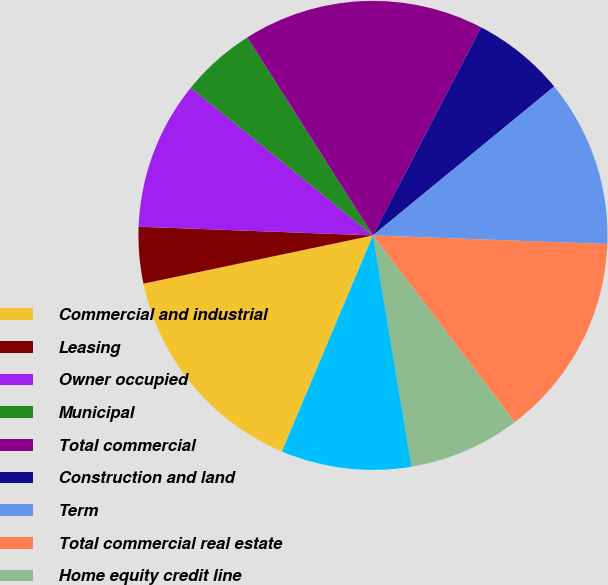Convert chart to OTSL. <chart><loc_0><loc_0><loc_500><loc_500><pie_chart><fcel>Commercial and industrial<fcel>Leasing<fcel>Owner occupied<fcel>Municipal<fcel>Total commercial<fcel>Construction and land<fcel>Term<fcel>Total commercial real estate<fcel>Home equity credit line<fcel>1-4 family residential<nl><fcel>15.35%<fcel>3.89%<fcel>10.25%<fcel>5.16%<fcel>16.62%<fcel>6.43%<fcel>11.53%<fcel>14.07%<fcel>7.71%<fcel>8.98%<nl></chart> 